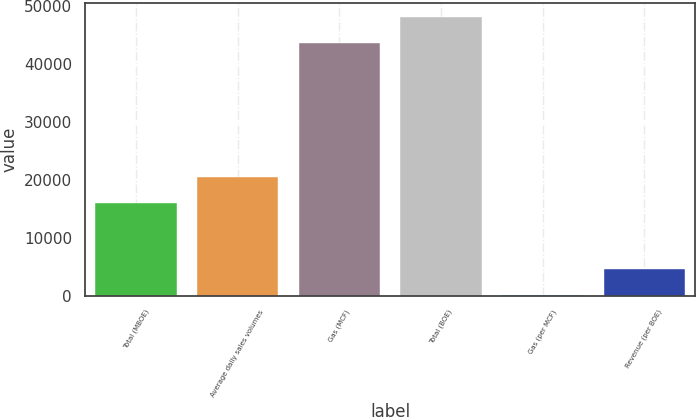Convert chart to OTSL. <chart><loc_0><loc_0><loc_500><loc_500><bar_chart><fcel>Total (MBOE)<fcel>Average daily sales volumes<fcel>Gas (MCF)<fcel>Total (BOE)<fcel>Gas (per MCF)<fcel>Revenue (per BOE)<nl><fcel>15899<fcel>20420.5<fcel>43559<fcel>48080.5<fcel>3.44<fcel>4524.9<nl></chart> 